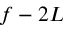Convert formula to latex. <formula><loc_0><loc_0><loc_500><loc_500>f - 2 L</formula> 